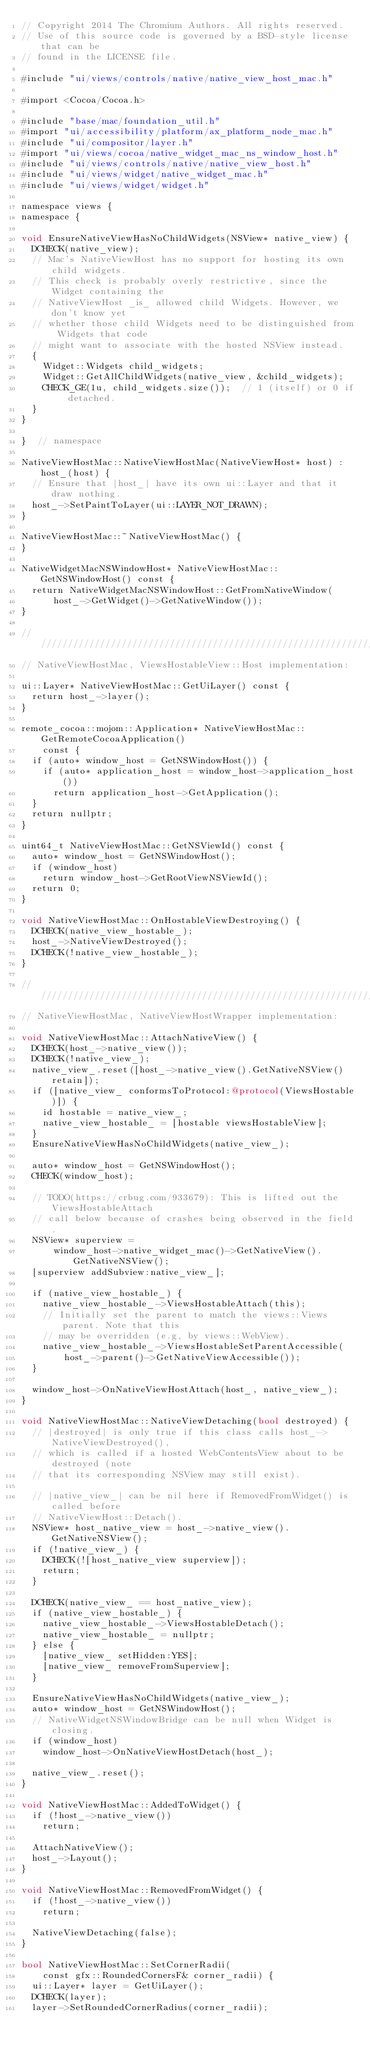<code> <loc_0><loc_0><loc_500><loc_500><_ObjectiveC_>// Copyright 2014 The Chromium Authors. All rights reserved.
// Use of this source code is governed by a BSD-style license that can be
// found in the LICENSE file.

#include "ui/views/controls/native/native_view_host_mac.h"

#import <Cocoa/Cocoa.h>

#include "base/mac/foundation_util.h"
#import "ui/accessibility/platform/ax_platform_node_mac.h"
#include "ui/compositor/layer.h"
#import "ui/views/cocoa/native_widget_mac_ns_window_host.h"
#include "ui/views/controls/native/native_view_host.h"
#include "ui/views/widget/native_widget_mac.h"
#include "ui/views/widget/widget.h"

namespace views {
namespace {

void EnsureNativeViewHasNoChildWidgets(NSView* native_view) {
  DCHECK(native_view);
  // Mac's NativeViewHost has no support for hosting its own child widgets.
  // This check is probably overly restrictive, since the Widget containing the
  // NativeViewHost _is_ allowed child Widgets. However, we don't know yet
  // whether those child Widgets need to be distinguished from Widgets that code
  // might want to associate with the hosted NSView instead.
  {
    Widget::Widgets child_widgets;
    Widget::GetAllChildWidgets(native_view, &child_widgets);
    CHECK_GE(1u, child_widgets.size());  // 1 (itself) or 0 if detached.
  }
}

}  // namespace

NativeViewHostMac::NativeViewHostMac(NativeViewHost* host) : host_(host) {
  // Ensure that |host_| have its own ui::Layer and that it draw nothing.
  host_->SetPaintToLayer(ui::LAYER_NOT_DRAWN);
}

NativeViewHostMac::~NativeViewHostMac() {
}

NativeWidgetMacNSWindowHost* NativeViewHostMac::GetNSWindowHost() const {
  return NativeWidgetMacNSWindowHost::GetFromNativeWindow(
      host_->GetWidget()->GetNativeWindow());
}

////////////////////////////////////////////////////////////////////////////////
// NativeViewHostMac, ViewsHostableView::Host implementation:

ui::Layer* NativeViewHostMac::GetUiLayer() const {
  return host_->layer();
}

remote_cocoa::mojom::Application* NativeViewHostMac::GetRemoteCocoaApplication()
    const {
  if (auto* window_host = GetNSWindowHost()) {
    if (auto* application_host = window_host->application_host())
      return application_host->GetApplication();
  }
  return nullptr;
}

uint64_t NativeViewHostMac::GetNSViewId() const {
  auto* window_host = GetNSWindowHost();
  if (window_host)
    return window_host->GetRootViewNSViewId();
  return 0;
}

void NativeViewHostMac::OnHostableViewDestroying() {
  DCHECK(native_view_hostable_);
  host_->NativeViewDestroyed();
  DCHECK(!native_view_hostable_);
}

////////////////////////////////////////////////////////////////////////////////
// NativeViewHostMac, NativeViewHostWrapper implementation:

void NativeViewHostMac::AttachNativeView() {
  DCHECK(host_->native_view());
  DCHECK(!native_view_);
  native_view_.reset([host_->native_view().GetNativeNSView() retain]);
  if ([native_view_ conformsToProtocol:@protocol(ViewsHostable)]) {
    id hostable = native_view_;
    native_view_hostable_ = [hostable viewsHostableView];
  }
  EnsureNativeViewHasNoChildWidgets(native_view_);

  auto* window_host = GetNSWindowHost();
  CHECK(window_host);

  // TODO(https://crbug.com/933679): This is lifted out the ViewsHostableAttach
  // call below because of crashes being observed in the field.
  NSView* superview =
      window_host->native_widget_mac()->GetNativeView().GetNativeNSView();
  [superview addSubview:native_view_];

  if (native_view_hostable_) {
    native_view_hostable_->ViewsHostableAttach(this);
    // Initially set the parent to match the views::Views parent. Note that this
    // may be overridden (e.g, by views::WebView).
    native_view_hostable_->ViewsHostableSetParentAccessible(
        host_->parent()->GetNativeViewAccessible());
  }

  window_host->OnNativeViewHostAttach(host_, native_view_);
}

void NativeViewHostMac::NativeViewDetaching(bool destroyed) {
  // |destroyed| is only true if this class calls host_->NativeViewDestroyed(),
  // which is called if a hosted WebContentsView about to be destroyed (note
  // that its corresponding NSView may still exist).

  // |native_view_| can be nil here if RemovedFromWidget() is called before
  // NativeViewHost::Detach().
  NSView* host_native_view = host_->native_view().GetNativeNSView();
  if (!native_view_) {
    DCHECK(![host_native_view superview]);
    return;
  }

  DCHECK(native_view_ == host_native_view);
  if (native_view_hostable_) {
    native_view_hostable_->ViewsHostableDetach();
    native_view_hostable_ = nullptr;
  } else {
    [native_view_ setHidden:YES];
    [native_view_ removeFromSuperview];
  }

  EnsureNativeViewHasNoChildWidgets(native_view_);
  auto* window_host = GetNSWindowHost();
  // NativeWidgetNSWindowBridge can be null when Widget is closing.
  if (window_host)
    window_host->OnNativeViewHostDetach(host_);

  native_view_.reset();
}

void NativeViewHostMac::AddedToWidget() {
  if (!host_->native_view())
    return;

  AttachNativeView();
  host_->Layout();
}

void NativeViewHostMac::RemovedFromWidget() {
  if (!host_->native_view())
    return;

  NativeViewDetaching(false);
}

bool NativeViewHostMac::SetCornerRadii(
    const gfx::RoundedCornersF& corner_radii) {
  ui::Layer* layer = GetUiLayer();
  DCHECK(layer);
  layer->SetRoundedCornerRadius(corner_radii);</code> 